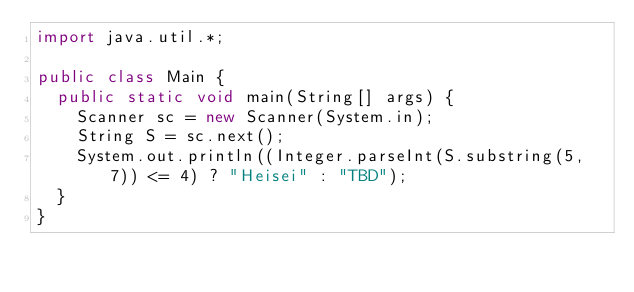Convert code to text. <code><loc_0><loc_0><loc_500><loc_500><_Java_>import java.util.*;

public class Main {
  public static void main(String[] args) {
    Scanner sc = new Scanner(System.in);
    String S = sc.next();
    System.out.println((Integer.parseInt(S.substring(5, 7)) <= 4) ? "Heisei" : "TBD");
  }
}</code> 